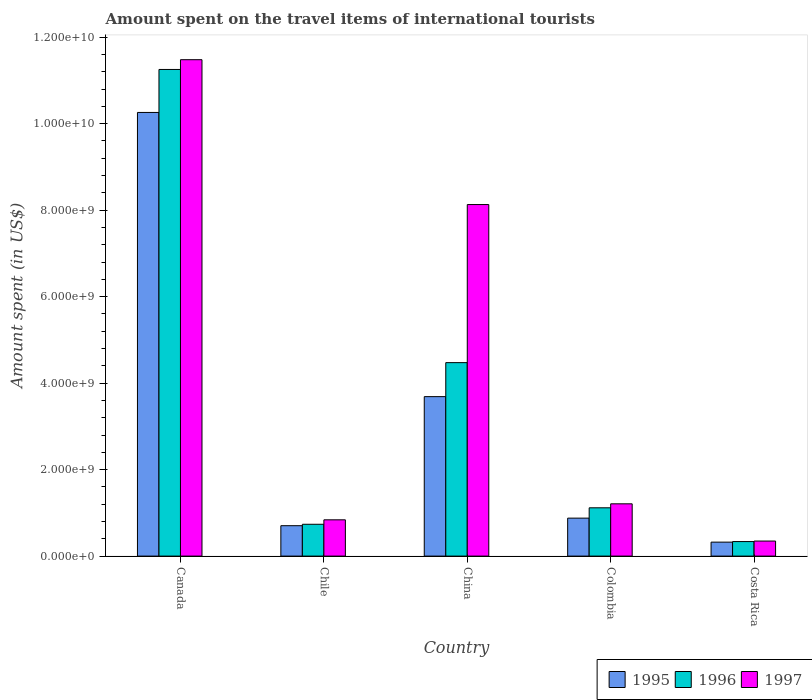How many groups of bars are there?
Offer a very short reply. 5. Are the number of bars on each tick of the X-axis equal?
Your response must be concise. Yes. How many bars are there on the 1st tick from the left?
Ensure brevity in your answer.  3. In how many cases, is the number of bars for a given country not equal to the number of legend labels?
Provide a short and direct response. 0. What is the amount spent on the travel items of international tourists in 1995 in Canada?
Your answer should be very brief. 1.03e+1. Across all countries, what is the maximum amount spent on the travel items of international tourists in 1997?
Your answer should be very brief. 1.15e+1. Across all countries, what is the minimum amount spent on the travel items of international tourists in 1996?
Provide a short and direct response. 3.36e+08. In which country was the amount spent on the travel items of international tourists in 1996 maximum?
Provide a short and direct response. Canada. What is the total amount spent on the travel items of international tourists in 1996 in the graph?
Your response must be concise. 1.79e+1. What is the difference between the amount spent on the travel items of international tourists in 1995 in Canada and that in Chile?
Offer a very short reply. 9.56e+09. What is the difference between the amount spent on the travel items of international tourists in 1995 in China and the amount spent on the travel items of international tourists in 1997 in Canada?
Provide a short and direct response. -7.79e+09. What is the average amount spent on the travel items of international tourists in 1996 per country?
Provide a short and direct response. 3.58e+09. What is the difference between the amount spent on the travel items of international tourists of/in 1996 and amount spent on the travel items of international tourists of/in 1995 in Costa Rica?
Offer a terse response. 1.30e+07. In how many countries, is the amount spent on the travel items of international tourists in 1997 greater than 6800000000 US$?
Your answer should be compact. 2. What is the ratio of the amount spent on the travel items of international tourists in 1997 in Chile to that in Colombia?
Offer a very short reply. 0.69. Is the amount spent on the travel items of international tourists in 1997 in China less than that in Costa Rica?
Keep it short and to the point. No. Is the difference between the amount spent on the travel items of international tourists in 1996 in China and Costa Rica greater than the difference between the amount spent on the travel items of international tourists in 1995 in China and Costa Rica?
Provide a short and direct response. Yes. What is the difference between the highest and the second highest amount spent on the travel items of international tourists in 1996?
Offer a very short reply. 1.01e+1. What is the difference between the highest and the lowest amount spent on the travel items of international tourists in 1997?
Your answer should be compact. 1.11e+1. In how many countries, is the amount spent on the travel items of international tourists in 1995 greater than the average amount spent on the travel items of international tourists in 1995 taken over all countries?
Keep it short and to the point. 2. Is the sum of the amount spent on the travel items of international tourists in 1995 in Chile and China greater than the maximum amount spent on the travel items of international tourists in 1997 across all countries?
Offer a very short reply. No. What does the 3rd bar from the right in Canada represents?
Provide a succinct answer. 1995. Are all the bars in the graph horizontal?
Your answer should be very brief. No. Are the values on the major ticks of Y-axis written in scientific E-notation?
Provide a short and direct response. Yes. Where does the legend appear in the graph?
Provide a short and direct response. Bottom right. What is the title of the graph?
Give a very brief answer. Amount spent on the travel items of international tourists. What is the label or title of the Y-axis?
Your answer should be compact. Amount spent (in US$). What is the Amount spent (in US$) of 1995 in Canada?
Provide a short and direct response. 1.03e+1. What is the Amount spent (in US$) of 1996 in Canada?
Provide a short and direct response. 1.13e+1. What is the Amount spent (in US$) of 1997 in Canada?
Provide a succinct answer. 1.15e+1. What is the Amount spent (in US$) of 1995 in Chile?
Provide a succinct answer. 7.03e+08. What is the Amount spent (in US$) in 1996 in Chile?
Your answer should be compact. 7.36e+08. What is the Amount spent (in US$) in 1997 in Chile?
Offer a terse response. 8.39e+08. What is the Amount spent (in US$) in 1995 in China?
Your answer should be very brief. 3.69e+09. What is the Amount spent (in US$) in 1996 in China?
Offer a very short reply. 4.47e+09. What is the Amount spent (in US$) of 1997 in China?
Keep it short and to the point. 8.13e+09. What is the Amount spent (in US$) of 1995 in Colombia?
Give a very brief answer. 8.78e+08. What is the Amount spent (in US$) in 1996 in Colombia?
Ensure brevity in your answer.  1.12e+09. What is the Amount spent (in US$) in 1997 in Colombia?
Provide a short and direct response. 1.21e+09. What is the Amount spent (in US$) in 1995 in Costa Rica?
Make the answer very short. 3.23e+08. What is the Amount spent (in US$) of 1996 in Costa Rica?
Ensure brevity in your answer.  3.36e+08. What is the Amount spent (in US$) in 1997 in Costa Rica?
Give a very brief answer. 3.48e+08. Across all countries, what is the maximum Amount spent (in US$) in 1995?
Provide a short and direct response. 1.03e+1. Across all countries, what is the maximum Amount spent (in US$) of 1996?
Offer a very short reply. 1.13e+1. Across all countries, what is the maximum Amount spent (in US$) in 1997?
Offer a terse response. 1.15e+1. Across all countries, what is the minimum Amount spent (in US$) in 1995?
Provide a short and direct response. 3.23e+08. Across all countries, what is the minimum Amount spent (in US$) of 1996?
Offer a terse response. 3.36e+08. Across all countries, what is the minimum Amount spent (in US$) of 1997?
Your response must be concise. 3.48e+08. What is the total Amount spent (in US$) in 1995 in the graph?
Give a very brief answer. 1.59e+1. What is the total Amount spent (in US$) of 1996 in the graph?
Offer a terse response. 1.79e+1. What is the total Amount spent (in US$) of 1997 in the graph?
Make the answer very short. 2.20e+1. What is the difference between the Amount spent (in US$) of 1995 in Canada and that in Chile?
Offer a terse response. 9.56e+09. What is the difference between the Amount spent (in US$) in 1996 in Canada and that in Chile?
Provide a succinct answer. 1.05e+1. What is the difference between the Amount spent (in US$) in 1997 in Canada and that in Chile?
Your answer should be compact. 1.06e+1. What is the difference between the Amount spent (in US$) in 1995 in Canada and that in China?
Your answer should be compact. 6.57e+09. What is the difference between the Amount spent (in US$) in 1996 in Canada and that in China?
Give a very brief answer. 6.78e+09. What is the difference between the Amount spent (in US$) in 1997 in Canada and that in China?
Provide a succinct answer. 3.35e+09. What is the difference between the Amount spent (in US$) of 1995 in Canada and that in Colombia?
Make the answer very short. 9.38e+09. What is the difference between the Amount spent (in US$) of 1996 in Canada and that in Colombia?
Provide a succinct answer. 1.01e+1. What is the difference between the Amount spent (in US$) in 1997 in Canada and that in Colombia?
Ensure brevity in your answer.  1.03e+1. What is the difference between the Amount spent (in US$) of 1995 in Canada and that in Costa Rica?
Keep it short and to the point. 9.94e+09. What is the difference between the Amount spent (in US$) of 1996 in Canada and that in Costa Rica?
Provide a short and direct response. 1.09e+1. What is the difference between the Amount spent (in US$) in 1997 in Canada and that in Costa Rica?
Offer a terse response. 1.11e+1. What is the difference between the Amount spent (in US$) of 1995 in Chile and that in China?
Make the answer very short. -2.98e+09. What is the difference between the Amount spent (in US$) of 1996 in Chile and that in China?
Offer a very short reply. -3.74e+09. What is the difference between the Amount spent (in US$) of 1997 in Chile and that in China?
Offer a terse response. -7.29e+09. What is the difference between the Amount spent (in US$) of 1995 in Chile and that in Colombia?
Give a very brief answer. -1.75e+08. What is the difference between the Amount spent (in US$) of 1996 in Chile and that in Colombia?
Offer a very short reply. -3.81e+08. What is the difference between the Amount spent (in US$) of 1997 in Chile and that in Colombia?
Provide a succinct answer. -3.70e+08. What is the difference between the Amount spent (in US$) of 1995 in Chile and that in Costa Rica?
Offer a terse response. 3.80e+08. What is the difference between the Amount spent (in US$) of 1996 in Chile and that in Costa Rica?
Give a very brief answer. 4.00e+08. What is the difference between the Amount spent (in US$) in 1997 in Chile and that in Costa Rica?
Ensure brevity in your answer.  4.91e+08. What is the difference between the Amount spent (in US$) of 1995 in China and that in Colombia?
Ensure brevity in your answer.  2.81e+09. What is the difference between the Amount spent (in US$) of 1996 in China and that in Colombia?
Offer a terse response. 3.36e+09. What is the difference between the Amount spent (in US$) of 1997 in China and that in Colombia?
Offer a terse response. 6.92e+09. What is the difference between the Amount spent (in US$) in 1995 in China and that in Costa Rica?
Offer a very short reply. 3.36e+09. What is the difference between the Amount spent (in US$) in 1996 in China and that in Costa Rica?
Ensure brevity in your answer.  4.14e+09. What is the difference between the Amount spent (in US$) of 1997 in China and that in Costa Rica?
Ensure brevity in your answer.  7.78e+09. What is the difference between the Amount spent (in US$) in 1995 in Colombia and that in Costa Rica?
Give a very brief answer. 5.55e+08. What is the difference between the Amount spent (in US$) in 1996 in Colombia and that in Costa Rica?
Your response must be concise. 7.81e+08. What is the difference between the Amount spent (in US$) in 1997 in Colombia and that in Costa Rica?
Ensure brevity in your answer.  8.61e+08. What is the difference between the Amount spent (in US$) in 1995 in Canada and the Amount spent (in US$) in 1996 in Chile?
Make the answer very short. 9.52e+09. What is the difference between the Amount spent (in US$) of 1995 in Canada and the Amount spent (in US$) of 1997 in Chile?
Your answer should be very brief. 9.42e+09. What is the difference between the Amount spent (in US$) in 1996 in Canada and the Amount spent (in US$) in 1997 in Chile?
Your answer should be compact. 1.04e+1. What is the difference between the Amount spent (in US$) in 1995 in Canada and the Amount spent (in US$) in 1996 in China?
Your answer should be compact. 5.79e+09. What is the difference between the Amount spent (in US$) of 1995 in Canada and the Amount spent (in US$) of 1997 in China?
Your answer should be compact. 2.13e+09. What is the difference between the Amount spent (in US$) in 1996 in Canada and the Amount spent (in US$) in 1997 in China?
Your answer should be very brief. 3.12e+09. What is the difference between the Amount spent (in US$) in 1995 in Canada and the Amount spent (in US$) in 1996 in Colombia?
Offer a very short reply. 9.14e+09. What is the difference between the Amount spent (in US$) of 1995 in Canada and the Amount spent (in US$) of 1997 in Colombia?
Make the answer very short. 9.05e+09. What is the difference between the Amount spent (in US$) of 1996 in Canada and the Amount spent (in US$) of 1997 in Colombia?
Give a very brief answer. 1.00e+1. What is the difference between the Amount spent (in US$) in 1995 in Canada and the Amount spent (in US$) in 1996 in Costa Rica?
Your answer should be very brief. 9.92e+09. What is the difference between the Amount spent (in US$) of 1995 in Canada and the Amount spent (in US$) of 1997 in Costa Rica?
Keep it short and to the point. 9.91e+09. What is the difference between the Amount spent (in US$) of 1996 in Canada and the Amount spent (in US$) of 1997 in Costa Rica?
Ensure brevity in your answer.  1.09e+1. What is the difference between the Amount spent (in US$) in 1995 in Chile and the Amount spent (in US$) in 1996 in China?
Your answer should be very brief. -3.77e+09. What is the difference between the Amount spent (in US$) in 1995 in Chile and the Amount spent (in US$) in 1997 in China?
Offer a terse response. -7.43e+09. What is the difference between the Amount spent (in US$) in 1996 in Chile and the Amount spent (in US$) in 1997 in China?
Your answer should be very brief. -7.39e+09. What is the difference between the Amount spent (in US$) in 1995 in Chile and the Amount spent (in US$) in 1996 in Colombia?
Ensure brevity in your answer.  -4.14e+08. What is the difference between the Amount spent (in US$) in 1995 in Chile and the Amount spent (in US$) in 1997 in Colombia?
Keep it short and to the point. -5.06e+08. What is the difference between the Amount spent (in US$) of 1996 in Chile and the Amount spent (in US$) of 1997 in Colombia?
Offer a very short reply. -4.73e+08. What is the difference between the Amount spent (in US$) in 1995 in Chile and the Amount spent (in US$) in 1996 in Costa Rica?
Offer a very short reply. 3.67e+08. What is the difference between the Amount spent (in US$) in 1995 in Chile and the Amount spent (in US$) in 1997 in Costa Rica?
Make the answer very short. 3.55e+08. What is the difference between the Amount spent (in US$) of 1996 in Chile and the Amount spent (in US$) of 1997 in Costa Rica?
Your answer should be very brief. 3.88e+08. What is the difference between the Amount spent (in US$) in 1995 in China and the Amount spent (in US$) in 1996 in Colombia?
Your answer should be compact. 2.57e+09. What is the difference between the Amount spent (in US$) of 1995 in China and the Amount spent (in US$) of 1997 in Colombia?
Provide a short and direct response. 2.48e+09. What is the difference between the Amount spent (in US$) of 1996 in China and the Amount spent (in US$) of 1997 in Colombia?
Provide a succinct answer. 3.26e+09. What is the difference between the Amount spent (in US$) of 1995 in China and the Amount spent (in US$) of 1996 in Costa Rica?
Offer a terse response. 3.35e+09. What is the difference between the Amount spent (in US$) in 1995 in China and the Amount spent (in US$) in 1997 in Costa Rica?
Provide a succinct answer. 3.34e+09. What is the difference between the Amount spent (in US$) in 1996 in China and the Amount spent (in US$) in 1997 in Costa Rica?
Keep it short and to the point. 4.13e+09. What is the difference between the Amount spent (in US$) in 1995 in Colombia and the Amount spent (in US$) in 1996 in Costa Rica?
Offer a terse response. 5.42e+08. What is the difference between the Amount spent (in US$) in 1995 in Colombia and the Amount spent (in US$) in 1997 in Costa Rica?
Offer a terse response. 5.30e+08. What is the difference between the Amount spent (in US$) in 1996 in Colombia and the Amount spent (in US$) in 1997 in Costa Rica?
Your answer should be very brief. 7.69e+08. What is the average Amount spent (in US$) of 1995 per country?
Your answer should be very brief. 3.17e+09. What is the average Amount spent (in US$) of 1996 per country?
Give a very brief answer. 3.58e+09. What is the average Amount spent (in US$) of 1997 per country?
Provide a succinct answer. 4.40e+09. What is the difference between the Amount spent (in US$) of 1995 and Amount spent (in US$) of 1996 in Canada?
Provide a succinct answer. -9.94e+08. What is the difference between the Amount spent (in US$) of 1995 and Amount spent (in US$) of 1997 in Canada?
Ensure brevity in your answer.  -1.22e+09. What is the difference between the Amount spent (in US$) of 1996 and Amount spent (in US$) of 1997 in Canada?
Your response must be concise. -2.26e+08. What is the difference between the Amount spent (in US$) of 1995 and Amount spent (in US$) of 1996 in Chile?
Make the answer very short. -3.30e+07. What is the difference between the Amount spent (in US$) in 1995 and Amount spent (in US$) in 1997 in Chile?
Your answer should be very brief. -1.36e+08. What is the difference between the Amount spent (in US$) of 1996 and Amount spent (in US$) of 1997 in Chile?
Provide a short and direct response. -1.03e+08. What is the difference between the Amount spent (in US$) of 1995 and Amount spent (in US$) of 1996 in China?
Your response must be concise. -7.86e+08. What is the difference between the Amount spent (in US$) in 1995 and Amount spent (in US$) in 1997 in China?
Ensure brevity in your answer.  -4.44e+09. What is the difference between the Amount spent (in US$) in 1996 and Amount spent (in US$) in 1997 in China?
Provide a short and direct response. -3.66e+09. What is the difference between the Amount spent (in US$) of 1995 and Amount spent (in US$) of 1996 in Colombia?
Ensure brevity in your answer.  -2.39e+08. What is the difference between the Amount spent (in US$) of 1995 and Amount spent (in US$) of 1997 in Colombia?
Your answer should be very brief. -3.31e+08. What is the difference between the Amount spent (in US$) in 1996 and Amount spent (in US$) in 1997 in Colombia?
Ensure brevity in your answer.  -9.20e+07. What is the difference between the Amount spent (in US$) in 1995 and Amount spent (in US$) in 1996 in Costa Rica?
Offer a very short reply. -1.30e+07. What is the difference between the Amount spent (in US$) of 1995 and Amount spent (in US$) of 1997 in Costa Rica?
Your response must be concise. -2.50e+07. What is the difference between the Amount spent (in US$) in 1996 and Amount spent (in US$) in 1997 in Costa Rica?
Your answer should be compact. -1.20e+07. What is the ratio of the Amount spent (in US$) in 1995 in Canada to that in Chile?
Keep it short and to the point. 14.59. What is the ratio of the Amount spent (in US$) in 1996 in Canada to that in Chile?
Offer a very short reply. 15.29. What is the ratio of the Amount spent (in US$) in 1997 in Canada to that in Chile?
Ensure brevity in your answer.  13.68. What is the ratio of the Amount spent (in US$) of 1995 in Canada to that in China?
Give a very brief answer. 2.78. What is the ratio of the Amount spent (in US$) of 1996 in Canada to that in China?
Your answer should be very brief. 2.52. What is the ratio of the Amount spent (in US$) of 1997 in Canada to that in China?
Give a very brief answer. 1.41. What is the ratio of the Amount spent (in US$) in 1995 in Canada to that in Colombia?
Offer a terse response. 11.69. What is the ratio of the Amount spent (in US$) of 1996 in Canada to that in Colombia?
Your answer should be very brief. 10.08. What is the ratio of the Amount spent (in US$) of 1997 in Canada to that in Colombia?
Provide a short and direct response. 9.5. What is the ratio of the Amount spent (in US$) in 1995 in Canada to that in Costa Rica?
Provide a short and direct response. 31.76. What is the ratio of the Amount spent (in US$) in 1996 in Canada to that in Costa Rica?
Provide a succinct answer. 33.49. What is the ratio of the Amount spent (in US$) of 1997 in Canada to that in Costa Rica?
Your answer should be very brief. 32.99. What is the ratio of the Amount spent (in US$) in 1995 in Chile to that in China?
Keep it short and to the point. 0.19. What is the ratio of the Amount spent (in US$) of 1996 in Chile to that in China?
Offer a terse response. 0.16. What is the ratio of the Amount spent (in US$) of 1997 in Chile to that in China?
Give a very brief answer. 0.1. What is the ratio of the Amount spent (in US$) in 1995 in Chile to that in Colombia?
Provide a short and direct response. 0.8. What is the ratio of the Amount spent (in US$) of 1996 in Chile to that in Colombia?
Make the answer very short. 0.66. What is the ratio of the Amount spent (in US$) of 1997 in Chile to that in Colombia?
Provide a short and direct response. 0.69. What is the ratio of the Amount spent (in US$) of 1995 in Chile to that in Costa Rica?
Offer a terse response. 2.18. What is the ratio of the Amount spent (in US$) in 1996 in Chile to that in Costa Rica?
Offer a terse response. 2.19. What is the ratio of the Amount spent (in US$) in 1997 in Chile to that in Costa Rica?
Offer a very short reply. 2.41. What is the ratio of the Amount spent (in US$) of 1995 in China to that in Colombia?
Offer a terse response. 4.2. What is the ratio of the Amount spent (in US$) of 1996 in China to that in Colombia?
Make the answer very short. 4.01. What is the ratio of the Amount spent (in US$) in 1997 in China to that in Colombia?
Your answer should be very brief. 6.72. What is the ratio of the Amount spent (in US$) in 1995 in China to that in Costa Rica?
Ensure brevity in your answer.  11.42. What is the ratio of the Amount spent (in US$) of 1996 in China to that in Costa Rica?
Give a very brief answer. 13.32. What is the ratio of the Amount spent (in US$) of 1997 in China to that in Costa Rica?
Keep it short and to the point. 23.36. What is the ratio of the Amount spent (in US$) of 1995 in Colombia to that in Costa Rica?
Give a very brief answer. 2.72. What is the ratio of the Amount spent (in US$) in 1996 in Colombia to that in Costa Rica?
Make the answer very short. 3.32. What is the ratio of the Amount spent (in US$) in 1997 in Colombia to that in Costa Rica?
Your response must be concise. 3.47. What is the difference between the highest and the second highest Amount spent (in US$) in 1995?
Keep it short and to the point. 6.57e+09. What is the difference between the highest and the second highest Amount spent (in US$) of 1996?
Keep it short and to the point. 6.78e+09. What is the difference between the highest and the second highest Amount spent (in US$) in 1997?
Give a very brief answer. 3.35e+09. What is the difference between the highest and the lowest Amount spent (in US$) in 1995?
Give a very brief answer. 9.94e+09. What is the difference between the highest and the lowest Amount spent (in US$) in 1996?
Keep it short and to the point. 1.09e+1. What is the difference between the highest and the lowest Amount spent (in US$) of 1997?
Your answer should be compact. 1.11e+1. 